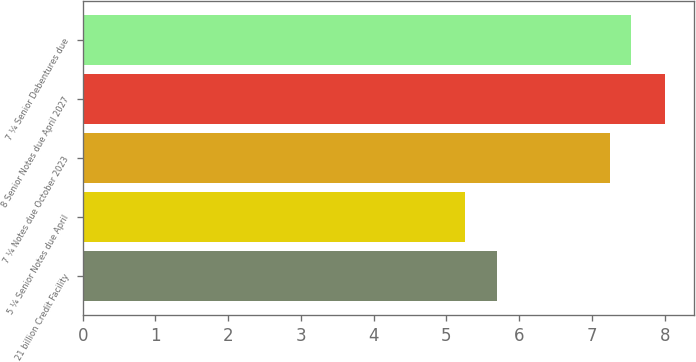<chart> <loc_0><loc_0><loc_500><loc_500><bar_chart><fcel>21 billion Credit Facility<fcel>5 ¼ Senior Notes due April<fcel>7 ¼ Notes due October 2023<fcel>8 Senior Notes due April 2027<fcel>7 ¼ Senior Debentures due<nl><fcel>5.69<fcel>5.25<fcel>7.25<fcel>8<fcel>7.53<nl></chart> 